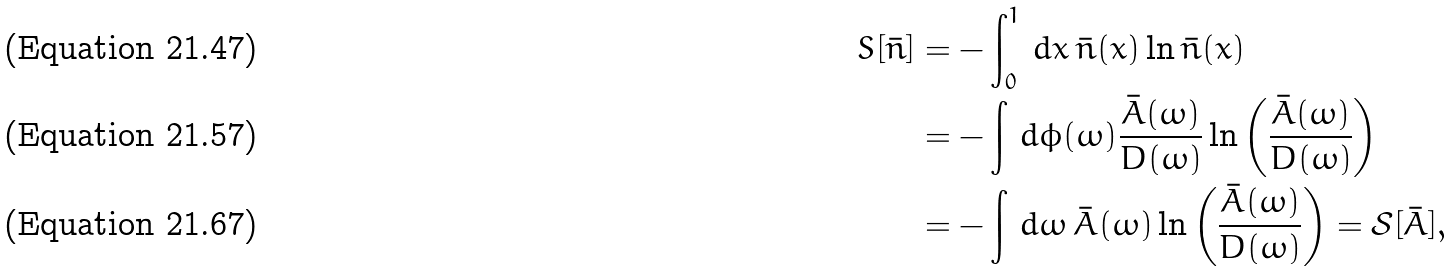Convert formula to latex. <formula><loc_0><loc_0><loc_500><loc_500>S [ \bar { n } ] & = - \int _ { 0 } ^ { 1 } \, d x \, \bar { n } ( x ) \ln \bar { n } ( x ) \\ & = - \int \, d \phi ( \omega ) \frac { \bar { A } ( \omega ) } { D ( \omega ) } \ln \left ( \frac { \bar { A } ( \omega ) } { D ( \omega ) } \right ) \\ & = - \int \, d \omega \, \bar { A } ( \omega ) \ln \left ( \frac { \bar { A } ( \omega ) } { D ( \omega ) } \right ) = \mathcal { S } [ \bar { A } ] ,</formula> 